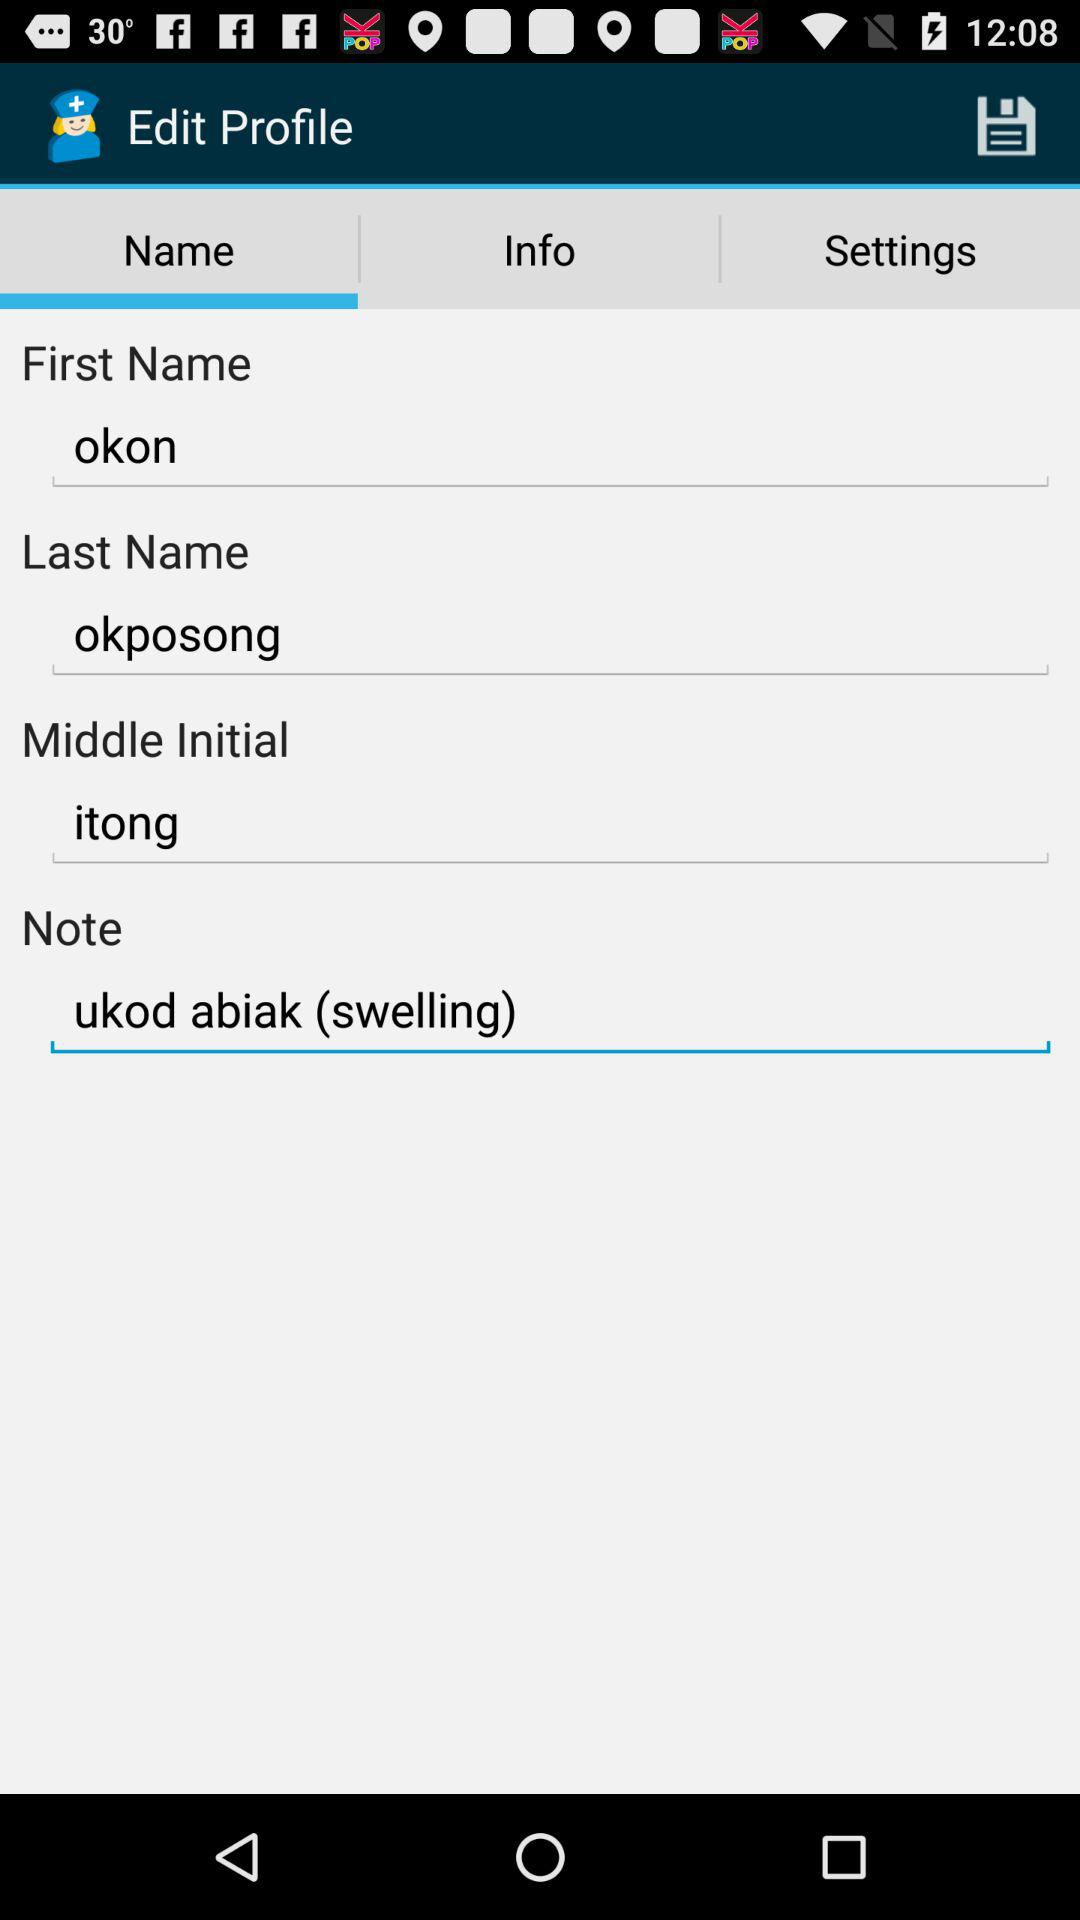What is the user's last name? The user's last name is okposong. 